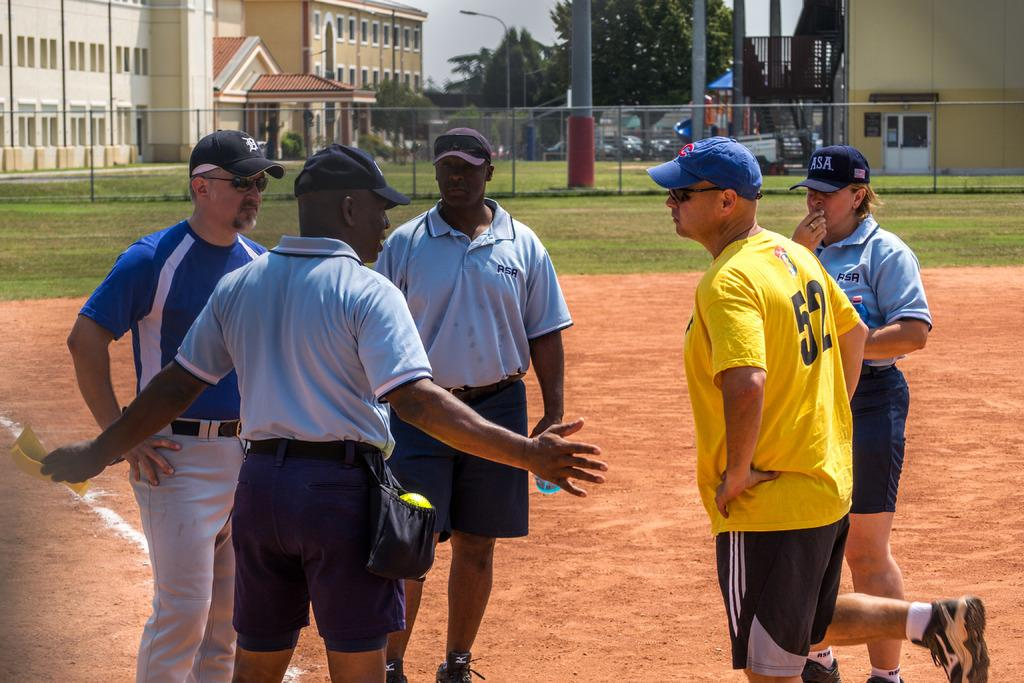Provide a one-sentence caption for the provided image. Number 52 listens to the umpire while standing near home plate. 